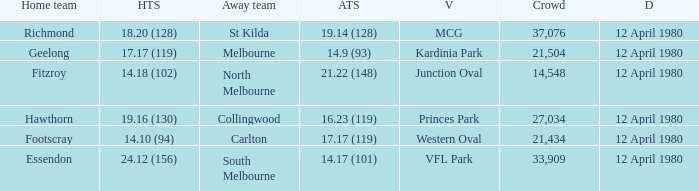Where did fitzroy play as the home team? Junction Oval. 